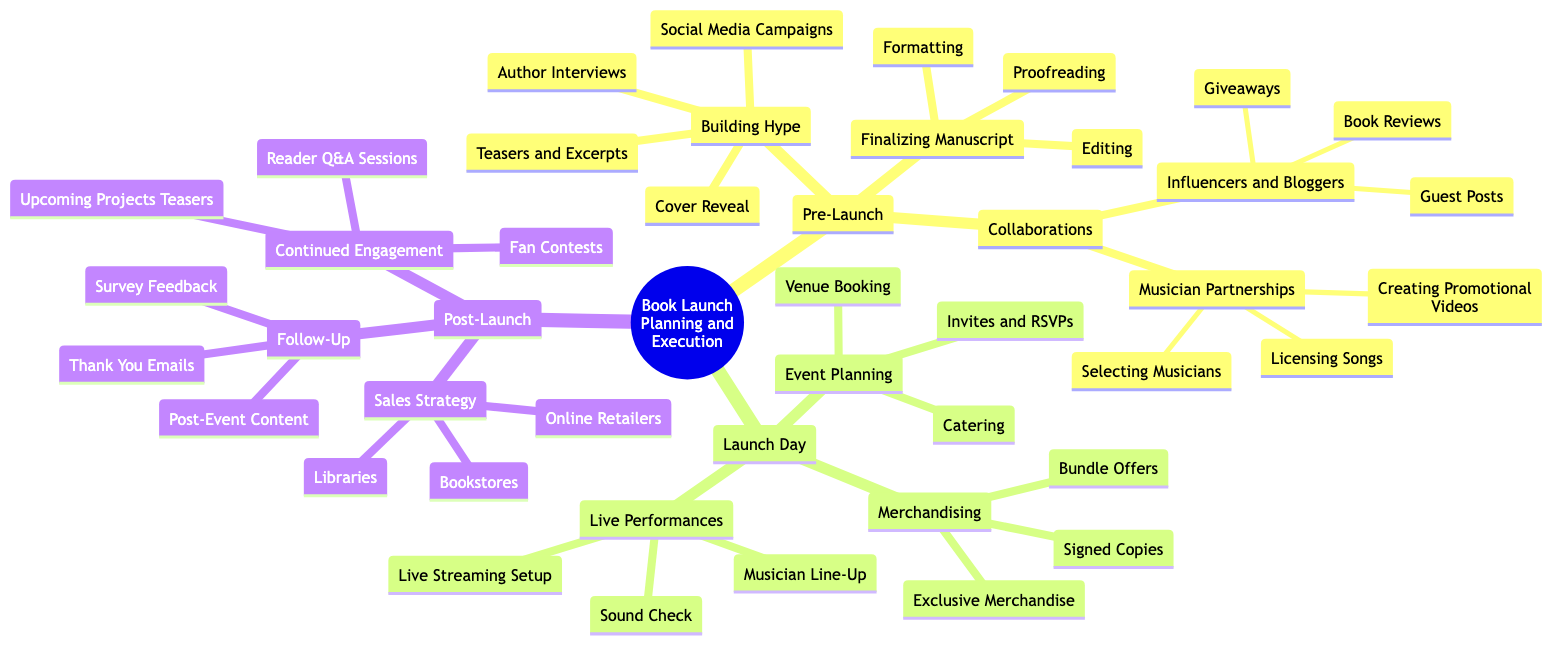What are the three main phases of the book launch process? The diagram is structured into three primary sections: Pre-Launch, Launch Day, and Post-Launch, each representing a phase in the overall book launch process.
Answer: Pre-Launch, Launch Day, Post-Launch How many activities are listed under "Building Hype"? The "Building Hype" category contains four distinct activities: Social Media Campaigns, Teasers and Excerpts, Author Interviews, and Cover Reveal, which can be counted directly from the diagram.
Answer: 4 Which task comes after "Editing" in the Pre-Launch phase? Under the "Finalizing Manuscript" node, "Editing" is listed first, followed by "Proofreading", indicating that Proofreading directly follows Editing in the sequence of tasks.
Answer: Proofreading What is the last node listed under "Sales Strategy"? The "Sales Strategy" section contains three elements, with "Libraries" being the last item in that list, as seen in the specified section of the diagram.
Answer: Libraries Which type of collaborations involve licensing songs? The "Musician Partnerships" node specifies activities related to collaborating with musicians, and it includes "Licensing Songs" as one of the listed tasks. Therefore, the type of collaboration that involves licensing songs is classified under "Musician Partnerships".
Answer: Musician Partnerships How many parts are included in "Follow-Up"? The "Follow-Up" section includes three parts: Thank You Emails, Post-Event Content, and Survey Feedback, which can be counted to determine the total number of components in that section.
Answer: 3 What is the main focus of the "Live Performances" section? The "Live Performances" section is structured around three essential components: Musician Line-Up, Sound Check, and Live Streaming Setup, which define the overall focus of this section during the launch day.
Answer: Musician Line-Up, Sound Check, Live Streaming Setup Which phase includes "Reader Q&A Sessions" as an activity? The "Reader Q&A Sessions" activity is listed under "Continued Engagement", which falls in the Post-Launch phase of the overall book launch process shown in the mind map.
Answer: Post-Launch What kind of merchandise is mentioned under "Merchandising"? The "Merchandising" category lists three types of items: Signed Copies, Exclusive Merchandise, and Bundle Offers, indicating the specific types of merchandise planned for the launch.
Answer: Signed Copies, Exclusive Merchandise, Bundle Offers 